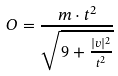<formula> <loc_0><loc_0><loc_500><loc_500>O = \frac { m \cdot t ^ { 2 } } { \sqrt { 9 + \frac { | v | ^ { 2 } } { t ^ { 2 } } } }</formula> 